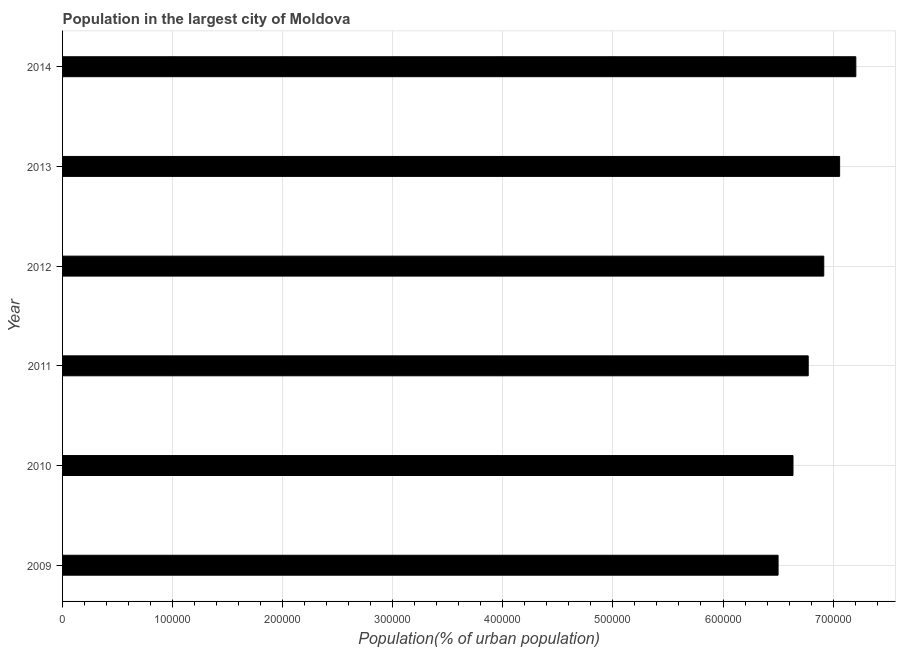Does the graph contain grids?
Provide a short and direct response. Yes. What is the title of the graph?
Give a very brief answer. Population in the largest city of Moldova. What is the label or title of the X-axis?
Offer a very short reply. Population(% of urban population). What is the label or title of the Y-axis?
Offer a terse response. Year. What is the population in largest city in 2010?
Offer a terse response. 6.64e+05. Across all years, what is the maximum population in largest city?
Keep it short and to the point. 7.21e+05. Across all years, what is the minimum population in largest city?
Give a very brief answer. 6.50e+05. In which year was the population in largest city minimum?
Offer a very short reply. 2009. What is the sum of the population in largest city?
Your answer should be very brief. 4.11e+06. What is the difference between the population in largest city in 2009 and 2013?
Provide a short and direct response. -5.59e+04. What is the average population in largest city per year?
Give a very brief answer. 6.85e+05. What is the median population in largest city?
Your answer should be very brief. 6.84e+05. In how many years, is the population in largest city greater than 360000 %?
Your response must be concise. 6. Do a majority of the years between 2013 and 2012 (inclusive) have population in largest city greater than 260000 %?
Your answer should be compact. No. What is the ratio of the population in largest city in 2010 to that in 2014?
Your answer should be very brief. 0.92. Is the difference between the population in largest city in 2012 and 2014 greater than the difference between any two years?
Make the answer very short. No. What is the difference between the highest and the second highest population in largest city?
Offer a very short reply. 1.47e+04. What is the difference between the highest and the lowest population in largest city?
Your answer should be very brief. 7.06e+04. In how many years, is the population in largest city greater than the average population in largest city taken over all years?
Your answer should be very brief. 3. Are all the bars in the graph horizontal?
Your answer should be very brief. Yes. Are the values on the major ticks of X-axis written in scientific E-notation?
Make the answer very short. No. What is the Population(% of urban population) in 2009?
Give a very brief answer. 6.50e+05. What is the Population(% of urban population) of 2010?
Offer a terse response. 6.64e+05. What is the Population(% of urban population) of 2011?
Your answer should be compact. 6.77e+05. What is the Population(% of urban population) in 2012?
Offer a very short reply. 6.92e+05. What is the Population(% of urban population) in 2013?
Ensure brevity in your answer.  7.06e+05. What is the Population(% of urban population) of 2014?
Make the answer very short. 7.21e+05. What is the difference between the Population(% of urban population) in 2009 and 2010?
Give a very brief answer. -1.36e+04. What is the difference between the Population(% of urban population) in 2009 and 2011?
Make the answer very short. -2.74e+04. What is the difference between the Population(% of urban population) in 2009 and 2012?
Make the answer very short. -4.15e+04. What is the difference between the Population(% of urban population) in 2009 and 2013?
Your answer should be compact. -5.59e+04. What is the difference between the Population(% of urban population) in 2009 and 2014?
Provide a succinct answer. -7.06e+04. What is the difference between the Population(% of urban population) in 2010 and 2011?
Offer a terse response. -1.38e+04. What is the difference between the Population(% of urban population) in 2010 and 2012?
Offer a terse response. -2.80e+04. What is the difference between the Population(% of urban population) in 2010 and 2013?
Your answer should be very brief. -4.24e+04. What is the difference between the Population(% of urban population) in 2010 and 2014?
Give a very brief answer. -5.71e+04. What is the difference between the Population(% of urban population) in 2011 and 2012?
Offer a very short reply. -1.41e+04. What is the difference between the Population(% of urban population) in 2011 and 2013?
Offer a very short reply. -2.85e+04. What is the difference between the Population(% of urban population) in 2011 and 2014?
Your response must be concise. -4.33e+04. What is the difference between the Population(% of urban population) in 2012 and 2013?
Keep it short and to the point. -1.44e+04. What is the difference between the Population(% of urban population) in 2012 and 2014?
Offer a terse response. -2.91e+04. What is the difference between the Population(% of urban population) in 2013 and 2014?
Offer a terse response. -1.47e+04. What is the ratio of the Population(% of urban population) in 2009 to that in 2011?
Offer a very short reply. 0.96. What is the ratio of the Population(% of urban population) in 2009 to that in 2013?
Provide a short and direct response. 0.92. What is the ratio of the Population(% of urban population) in 2009 to that in 2014?
Provide a short and direct response. 0.9. What is the ratio of the Population(% of urban population) in 2010 to that in 2011?
Keep it short and to the point. 0.98. What is the ratio of the Population(% of urban population) in 2010 to that in 2013?
Ensure brevity in your answer.  0.94. What is the ratio of the Population(% of urban population) in 2010 to that in 2014?
Your answer should be very brief. 0.92. What is the ratio of the Population(% of urban population) in 2011 to that in 2012?
Your response must be concise. 0.98. What is the ratio of the Population(% of urban population) in 2012 to that in 2013?
Offer a very short reply. 0.98. What is the ratio of the Population(% of urban population) in 2013 to that in 2014?
Give a very brief answer. 0.98. 